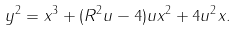Convert formula to latex. <formula><loc_0><loc_0><loc_500><loc_500>y ^ { 2 } = x ^ { 3 } + ( R ^ { 2 } u - 4 ) u x ^ { 2 } + 4 u ^ { 2 } x .</formula> 